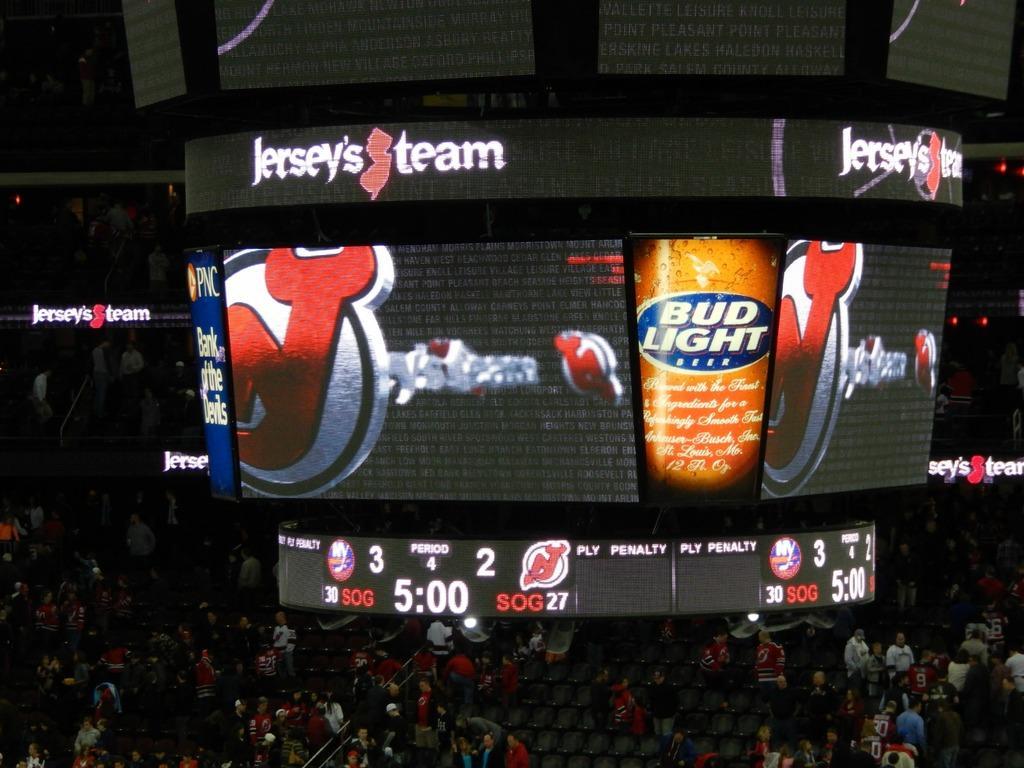Describe this image in one or two sentences. In the image I can see people, chairs and some other objects. Here I can see screens on which I can see something is displaying screens. 